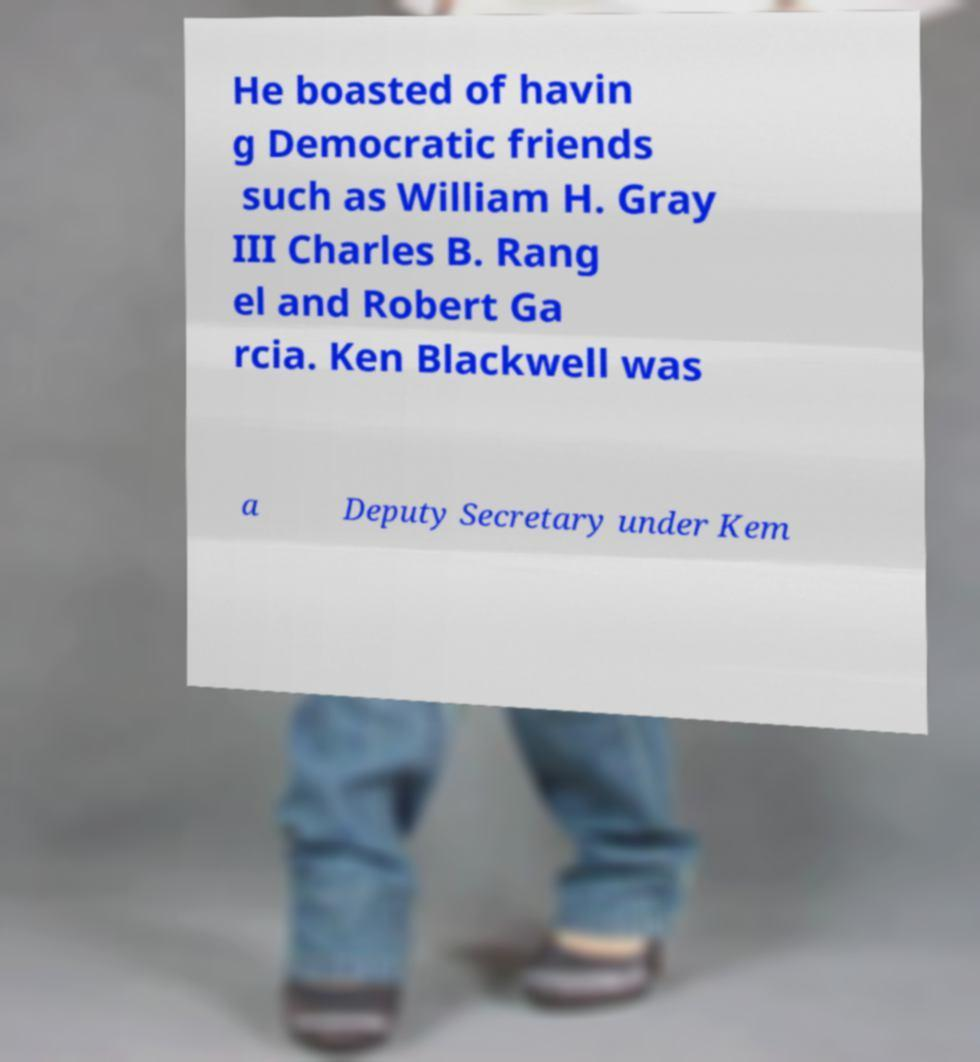For documentation purposes, I need the text within this image transcribed. Could you provide that? He boasted of havin g Democratic friends such as William H. Gray III Charles B. Rang el and Robert Ga rcia. Ken Blackwell was a Deputy Secretary under Kem 